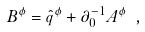<formula> <loc_0><loc_0><loc_500><loc_500>B ^ { \phi } = \hat { q } ^ { \phi } + \partial _ { 0 } ^ { - 1 } A ^ { \phi } \ ,</formula> 